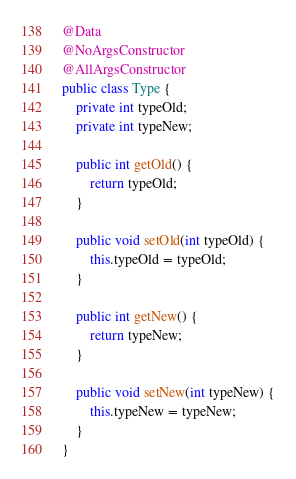<code> <loc_0><loc_0><loc_500><loc_500><_Java_>
@Data
@NoArgsConstructor
@AllArgsConstructor
public class Type {
    private int typeOld;
    private int typeNew;

    public int getOld() {
        return typeOld;
    }

    public void setOld(int typeOld) {
        this.typeOld = typeOld;
    }

    public int getNew() {
        return typeNew;
    }

    public void setNew(int typeNew) {
        this.typeNew = typeNew;
    }
}
</code> 